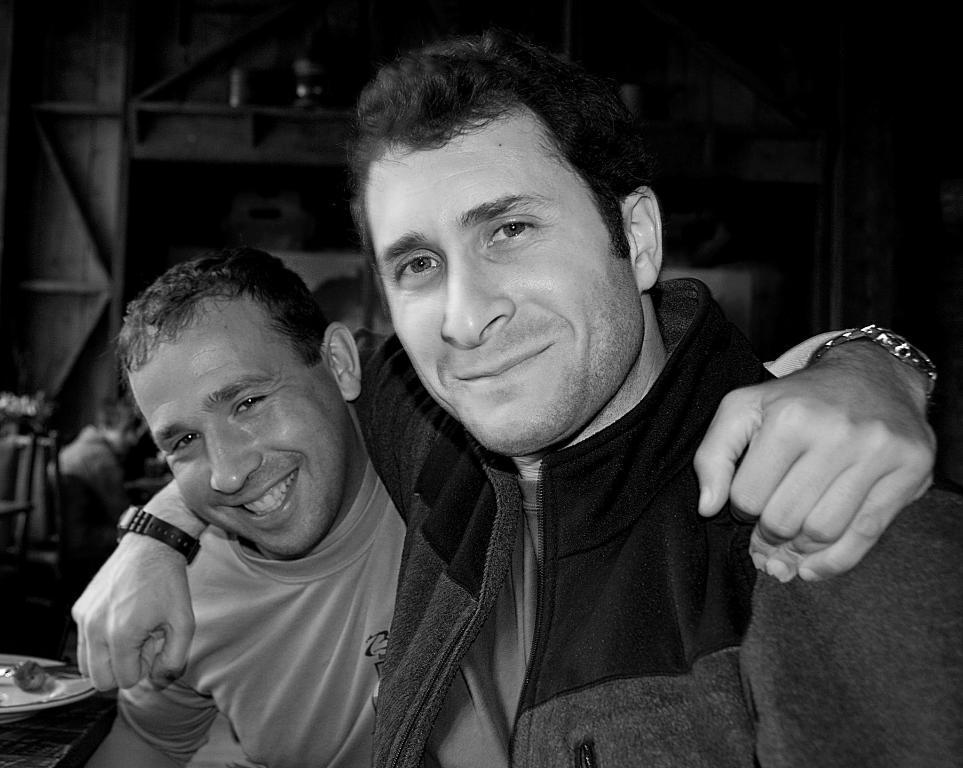Please provide a concise description of this image. This is a black and white image. Here I can see two men are smiling and giving pose for the picture. I can see the witches to their hands. In the background there is a wall and I can see a person is sitting on the chair. 